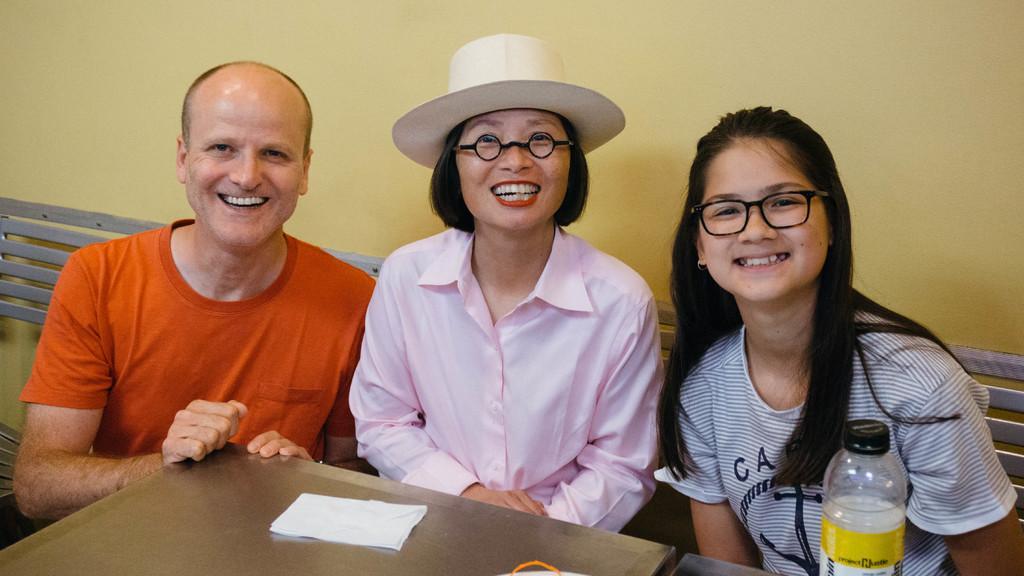How would you summarize this image in a sentence or two? In the middle of the image there persons are sitting and smiling. Behind them there is a wall. Bottom of the image there is a table on the table there is a paper and there is a bottle. 